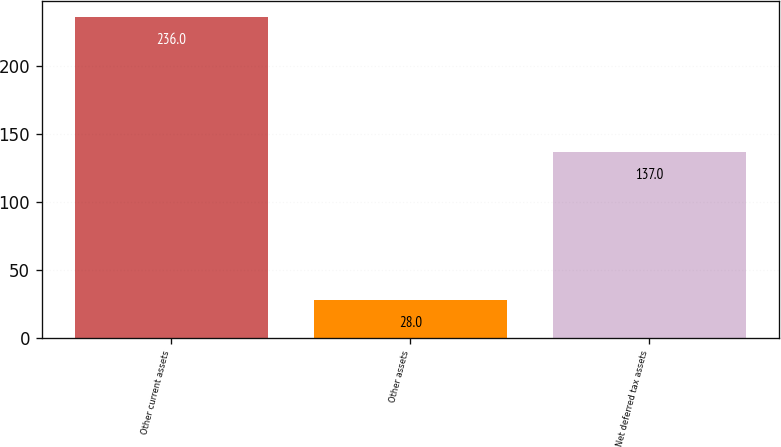Convert chart to OTSL. <chart><loc_0><loc_0><loc_500><loc_500><bar_chart><fcel>Other current assets<fcel>Other assets<fcel>Net deferred tax assets<nl><fcel>236<fcel>28<fcel>137<nl></chart> 